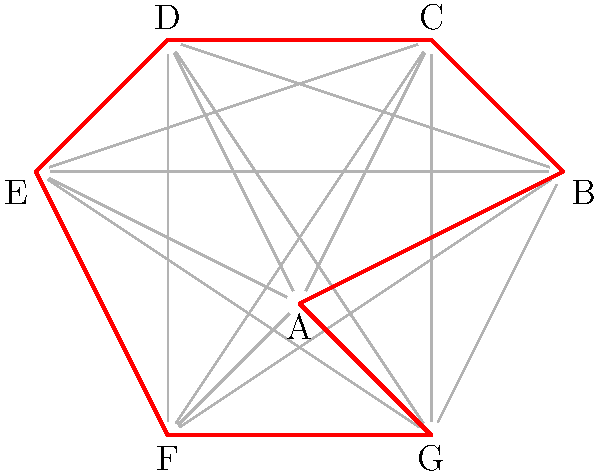As a garden designer in New Zealand, you're planning a tour path for visitors to view all garden features in a new botanical garden. The garden has 7 main features (A to G) connected by pathways. You want to find a Hamiltonian cycle that allows visitors to see all features exactly once and return to the starting point. Given the graph above, where vertices represent garden features and edges represent pathways, how many different Hamiltonian cycles exist in this graph? To solve this problem, we'll follow these steps:

1) First, note that in a Hamiltonian cycle for a graph with 7 vertices, we need to choose 7 edges that form a cycle visiting each vertex once.

2) We can start at any vertex (let's choose A) and count the number of possible paths.

3) From A, we have 6 choices for the second vertex.

4) For the third vertex, we have 5 choices, as we can't return to A or repeat the second vertex.

5) This continues until we reach the last vertex, where we only have one choice to return to A.

6) This gives us: 6 * 5 * 4 * 3 * 2 * 1 = 720 possible paths.

7) However, this counts each cycle twice (once in each direction) and from 7 different starting points.

8) So, we need to divide our total by 14 (2 * 7) to account for these duplicates.

9) 720 / 14 = 51.4, which rounds down to 51 as we can only have whole cycles.

Therefore, there are 51 different Hamiltonian cycles in this graph.
Answer: 51 